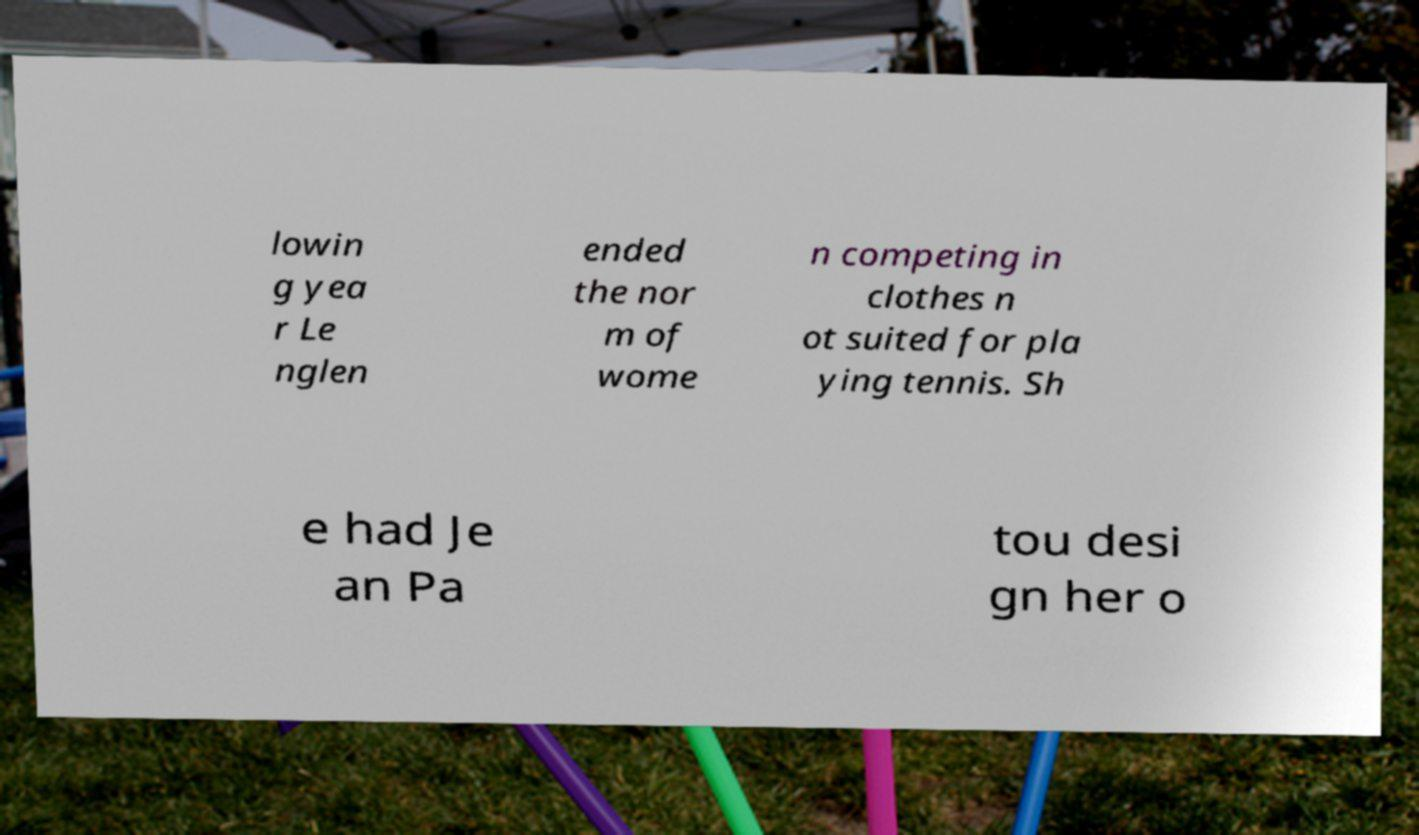There's text embedded in this image that I need extracted. Can you transcribe it verbatim? lowin g yea r Le nglen ended the nor m of wome n competing in clothes n ot suited for pla ying tennis. Sh e had Je an Pa tou desi gn her o 